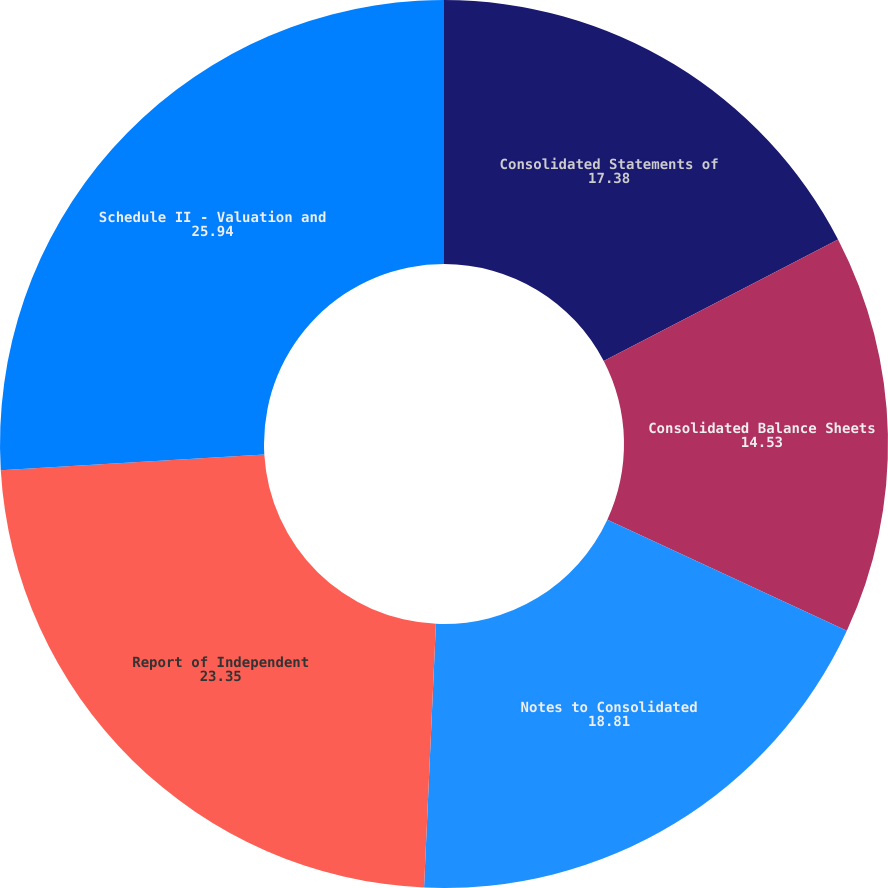Convert chart to OTSL. <chart><loc_0><loc_0><loc_500><loc_500><pie_chart><fcel>Consolidated Statements of<fcel>Consolidated Balance Sheets<fcel>Notes to Consolidated<fcel>Report of Independent<fcel>Schedule II - Valuation and<nl><fcel>17.38%<fcel>14.53%<fcel>18.81%<fcel>23.35%<fcel>25.94%<nl></chart> 